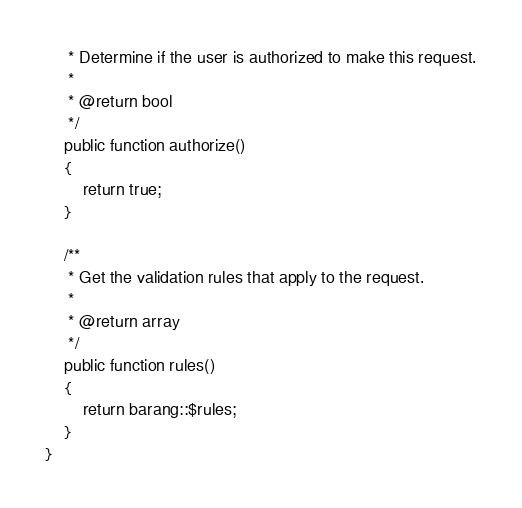Convert code to text. <code><loc_0><loc_0><loc_500><loc_500><_PHP_>     * Determine if the user is authorized to make this request.
     *
     * @return bool
     */
    public function authorize()
    {
        return true;
    }

    /**
     * Get the validation rules that apply to the request.
     *
     * @return array
     */
    public function rules()
    {
        return barang::$rules;
    }
}
</code> 